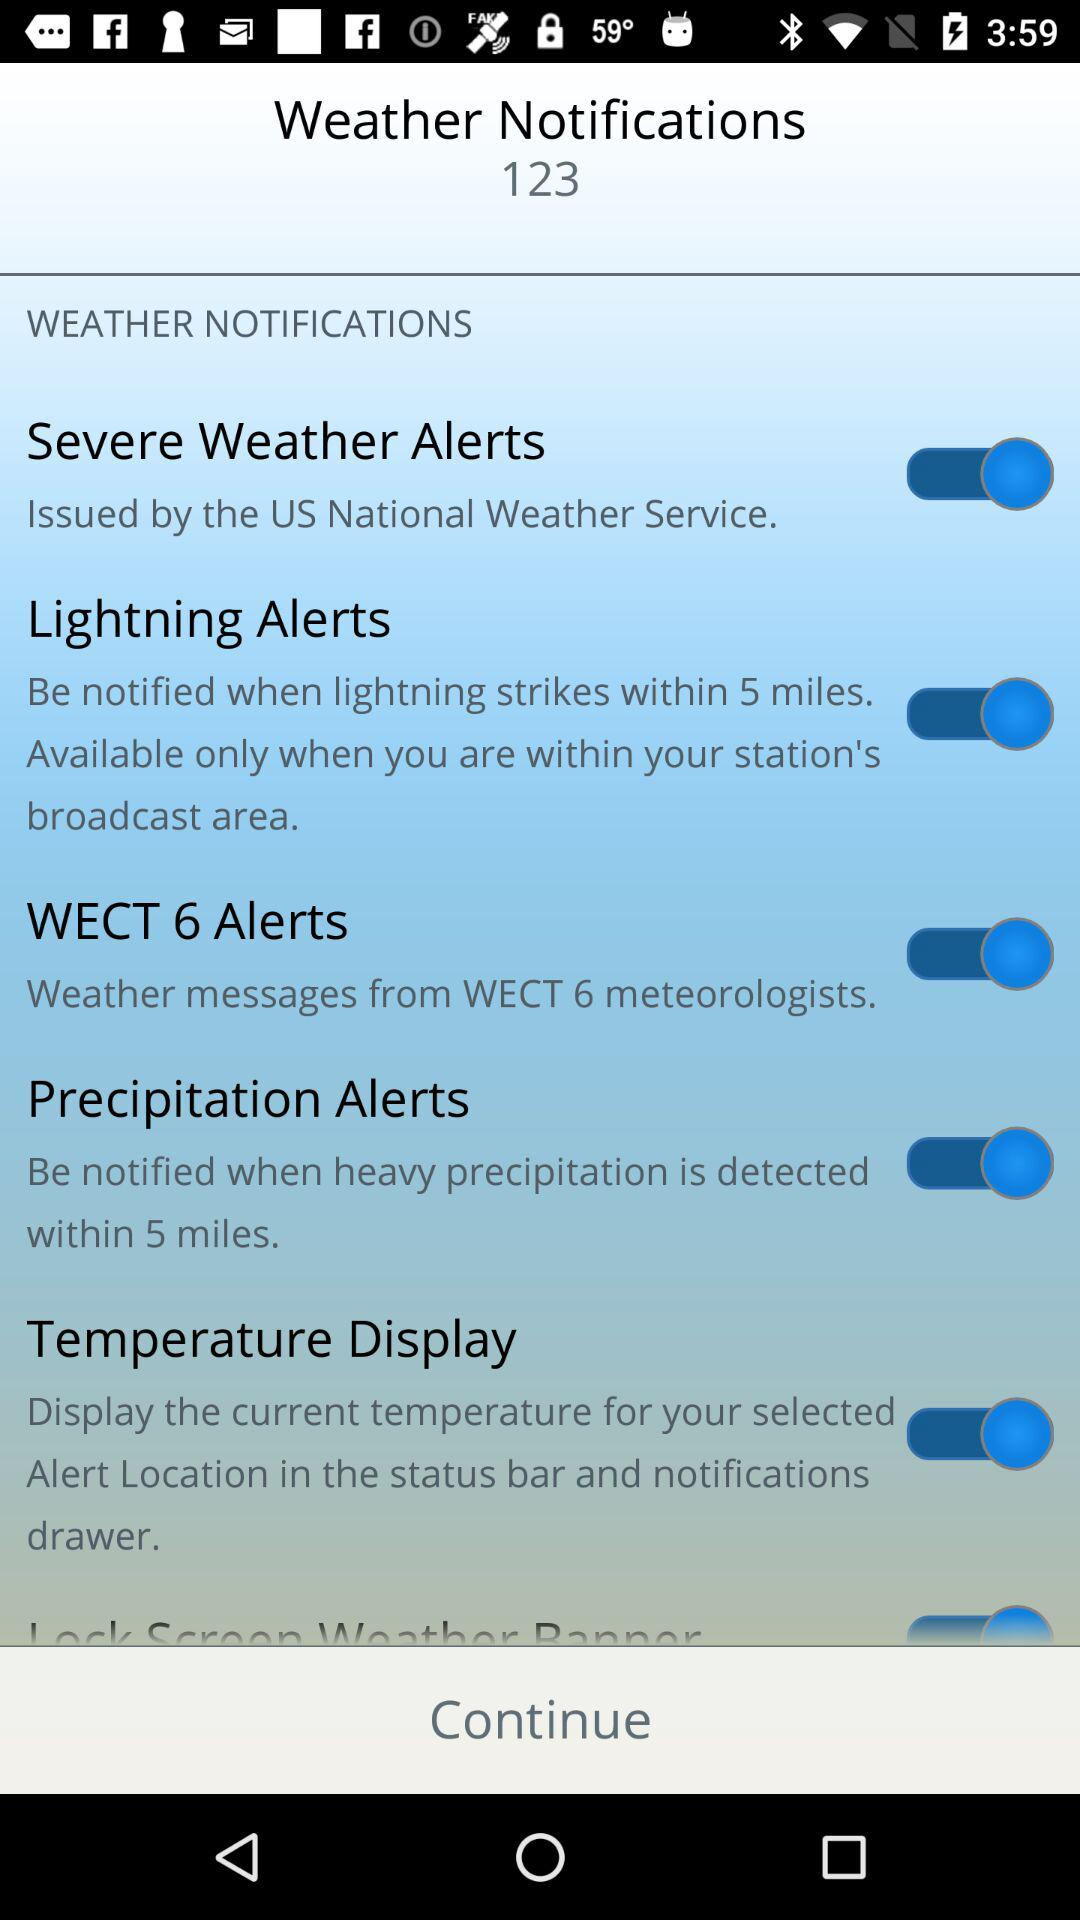What is the current status of the "Severe Weather Alerts"? The status is "on". 